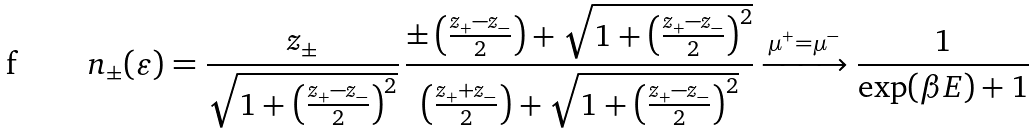<formula> <loc_0><loc_0><loc_500><loc_500>n _ { \pm } ( \varepsilon ) = \frac { z _ { \pm } } { \sqrt { 1 + \left ( \frac { z _ { + } - z _ { - } } { 2 } \right ) ^ { 2 } } } \, \frac { \pm \left ( \frac { z _ { + } - z _ { - } } { 2 } \right ) + \sqrt { 1 + \left ( \frac { z _ { + } - z _ { - } } { 2 } \right ) ^ { 2 } } } { \left ( \frac { z _ { + } + z _ { - } } { 2 } \right ) + \sqrt { 1 + \left ( \frac { z _ { + } - z _ { - } } { 2 } \right ) ^ { 2 } } } \xrightarrow { \mu ^ { + } = \mu ^ { - } } \frac { 1 } { \exp ( \beta E ) + 1 }</formula> 